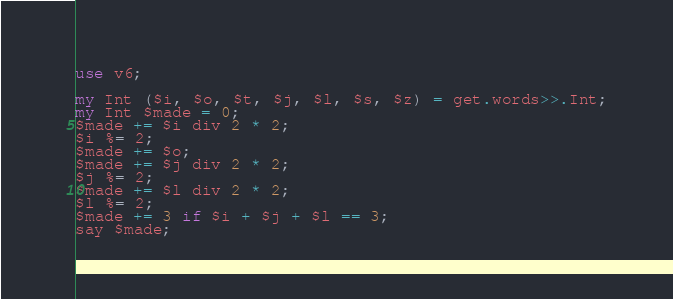<code> <loc_0><loc_0><loc_500><loc_500><_Perl_>use v6;

my Int ($i, $o, $t, $j, $l, $s, $z) = get.words>>.Int;
my Int $made = 0;
$made += $i div 2 * 2;
$i %= 2;
$made += $o;
$made += $j div 2 * 2;
$j %= 2;
$made += $l div 2 * 2;
$l %= 2;
$made += 3 if $i + $j + $l == 3;
say $made;
</code> 